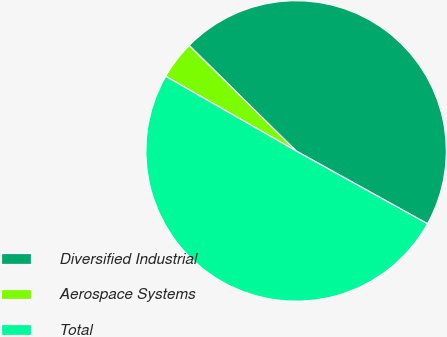<chart> <loc_0><loc_0><loc_500><loc_500><pie_chart><fcel>Diversified Industrial<fcel>Aerospace Systems<fcel>Total<nl><fcel>45.66%<fcel>4.12%<fcel>50.22%<nl></chart> 